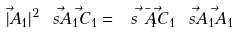<formula> <loc_0><loc_0><loc_500><loc_500>| \vec { A } _ { 1 } | ^ { 2 } \ s { \vec { A } _ { 1 } } { \vec { C } _ { 1 } } = \ s { \bar { \vec { A } _ { 1 } } } { \vec { C } _ { 1 } } \ s { \vec { A } _ { 1 } } { \vec { A } _ { 1 } }</formula> 